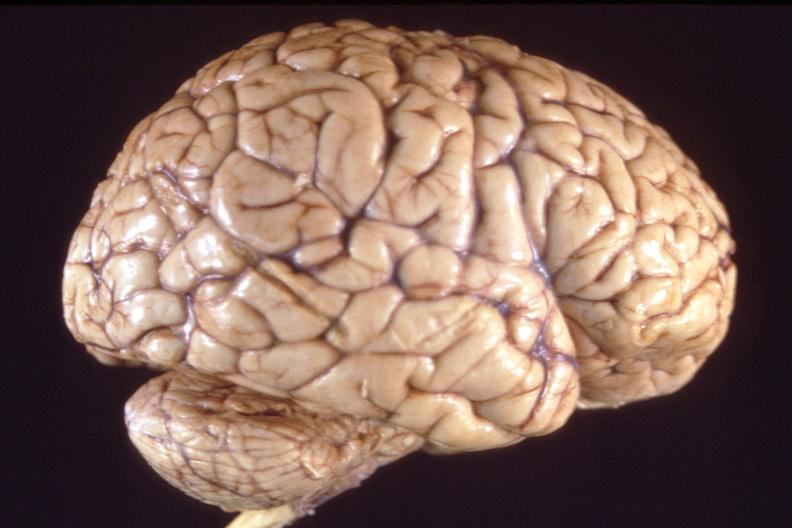does muscle atrophy show brain, breast cancer metastasis to meninges?
Answer the question using a single word or phrase. No 